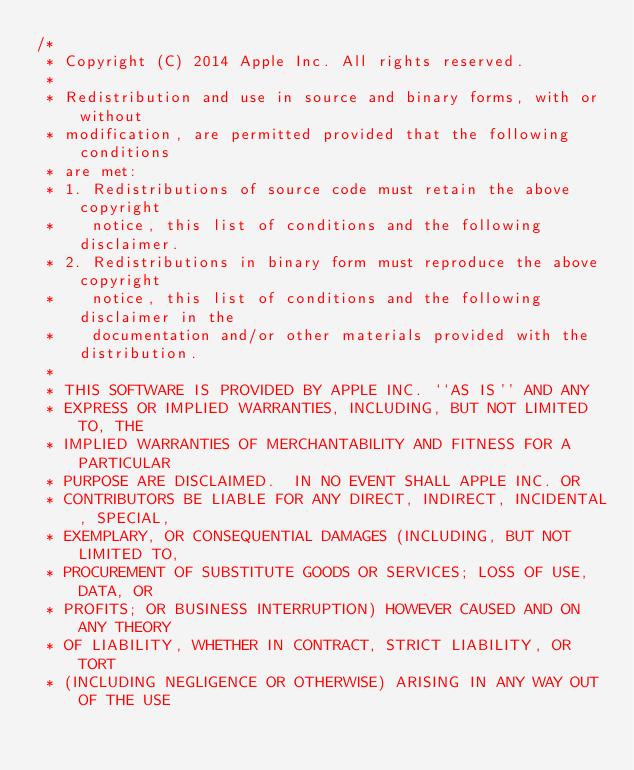<code> <loc_0><loc_0><loc_500><loc_500><_C_>/*
 * Copyright (C) 2014 Apple Inc. All rights reserved.
 *
 * Redistribution and use in source and binary forms, with or without
 * modification, are permitted provided that the following conditions
 * are met:
 * 1. Redistributions of source code must retain the above copyright
 *    notice, this list of conditions and the following disclaimer.
 * 2. Redistributions in binary form must reproduce the above copyright
 *    notice, this list of conditions and the following disclaimer in the
 *    documentation and/or other materials provided with the distribution.
 *
 * THIS SOFTWARE IS PROVIDED BY APPLE INC. ``AS IS'' AND ANY
 * EXPRESS OR IMPLIED WARRANTIES, INCLUDING, BUT NOT LIMITED TO, THE
 * IMPLIED WARRANTIES OF MERCHANTABILITY AND FITNESS FOR A PARTICULAR
 * PURPOSE ARE DISCLAIMED.  IN NO EVENT SHALL APPLE INC. OR
 * CONTRIBUTORS BE LIABLE FOR ANY DIRECT, INDIRECT, INCIDENTAL, SPECIAL,
 * EXEMPLARY, OR CONSEQUENTIAL DAMAGES (INCLUDING, BUT NOT LIMITED TO,
 * PROCUREMENT OF SUBSTITUTE GOODS OR SERVICES; LOSS OF USE, DATA, OR
 * PROFITS; OR BUSINESS INTERRUPTION) HOWEVER CAUSED AND ON ANY THEORY
 * OF LIABILITY, WHETHER IN CONTRACT, STRICT LIABILITY, OR TORT
 * (INCLUDING NEGLIGENCE OR OTHERWISE) ARISING IN ANY WAY OUT OF THE USE</code> 